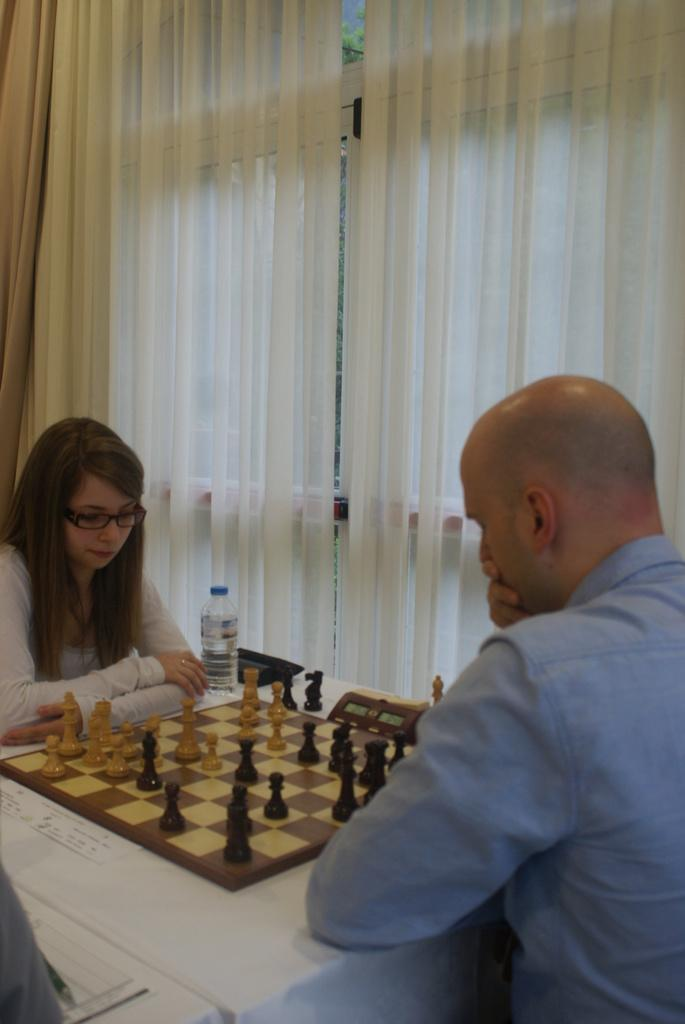Who are the people in the image? There is a woman and a man in the image. What are the woman and the man doing in the image? Both the woman and the man are sitting on chairs. What is on the table in the image? There is a chessboard and a bottle on the table. What can be seen in the background of the image? There is a curtain in the image. What type of rock is being used as a chess piece in the image? There is no rock being used as a chess piece in the image; the chessboard has traditional chess pieces made of materials such as plastic or wood. 